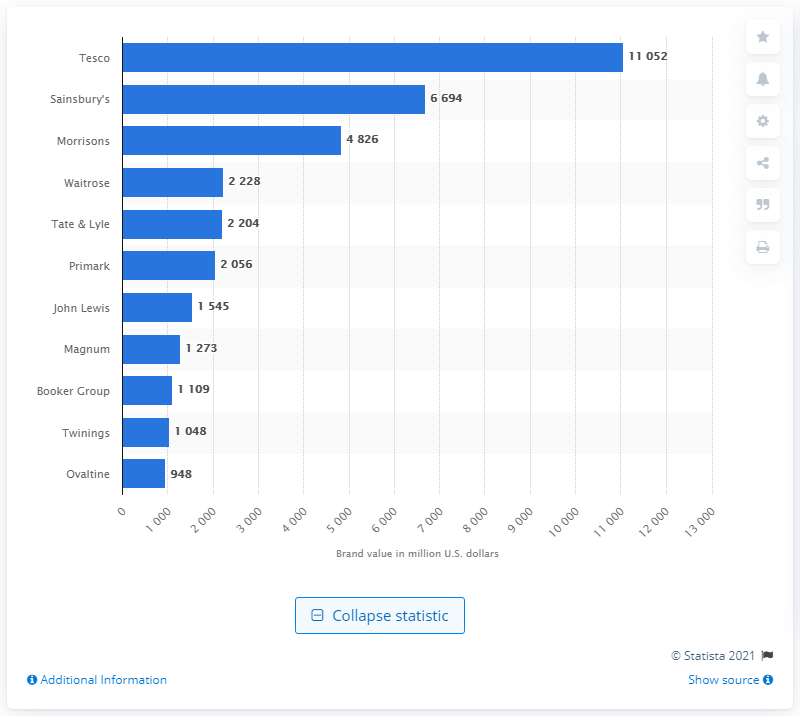Identify some key points in this picture. In 2015, Sainsbury's was the second most valuable food brand in the UK, preceded only by Tesco. In 2015, Tesco was the most valuable food brand in the United Kingdom. As of December 31, 2014, Tesco's brand value was 11,052. 